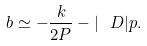<formula> <loc_0><loc_0><loc_500><loc_500>b \simeq - \frac { k } { 2 P } - | \ D | p .</formula> 